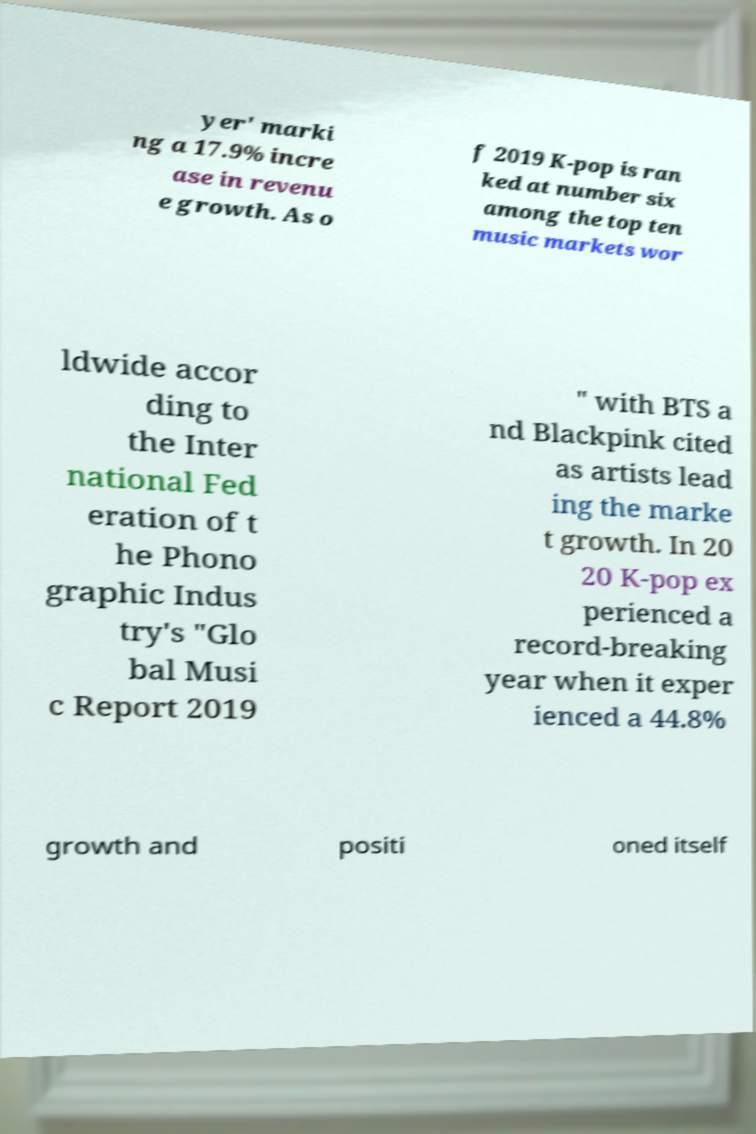I need the written content from this picture converted into text. Can you do that? yer' marki ng a 17.9% incre ase in revenu e growth. As o f 2019 K-pop is ran ked at number six among the top ten music markets wor ldwide accor ding to the Inter national Fed eration of t he Phono graphic Indus try's "Glo bal Musi c Report 2019 " with BTS a nd Blackpink cited as artists lead ing the marke t growth. In 20 20 K-pop ex perienced a record-breaking year when it exper ienced a 44.8% growth and positi oned itself 